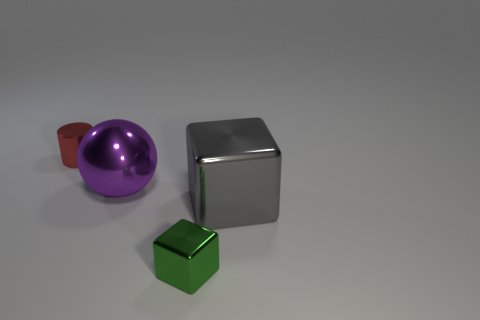Subtract all green blocks. How many blocks are left? 1 Subtract all cylinders. How many objects are left? 3 Add 2 small metal cylinders. How many objects exist? 6 Add 1 small shiny blocks. How many small shiny blocks are left? 2 Add 1 small yellow things. How many small yellow things exist? 1 Subtract 0 yellow spheres. How many objects are left? 4 Subtract all small shiny things. Subtract all gray metal things. How many objects are left? 1 